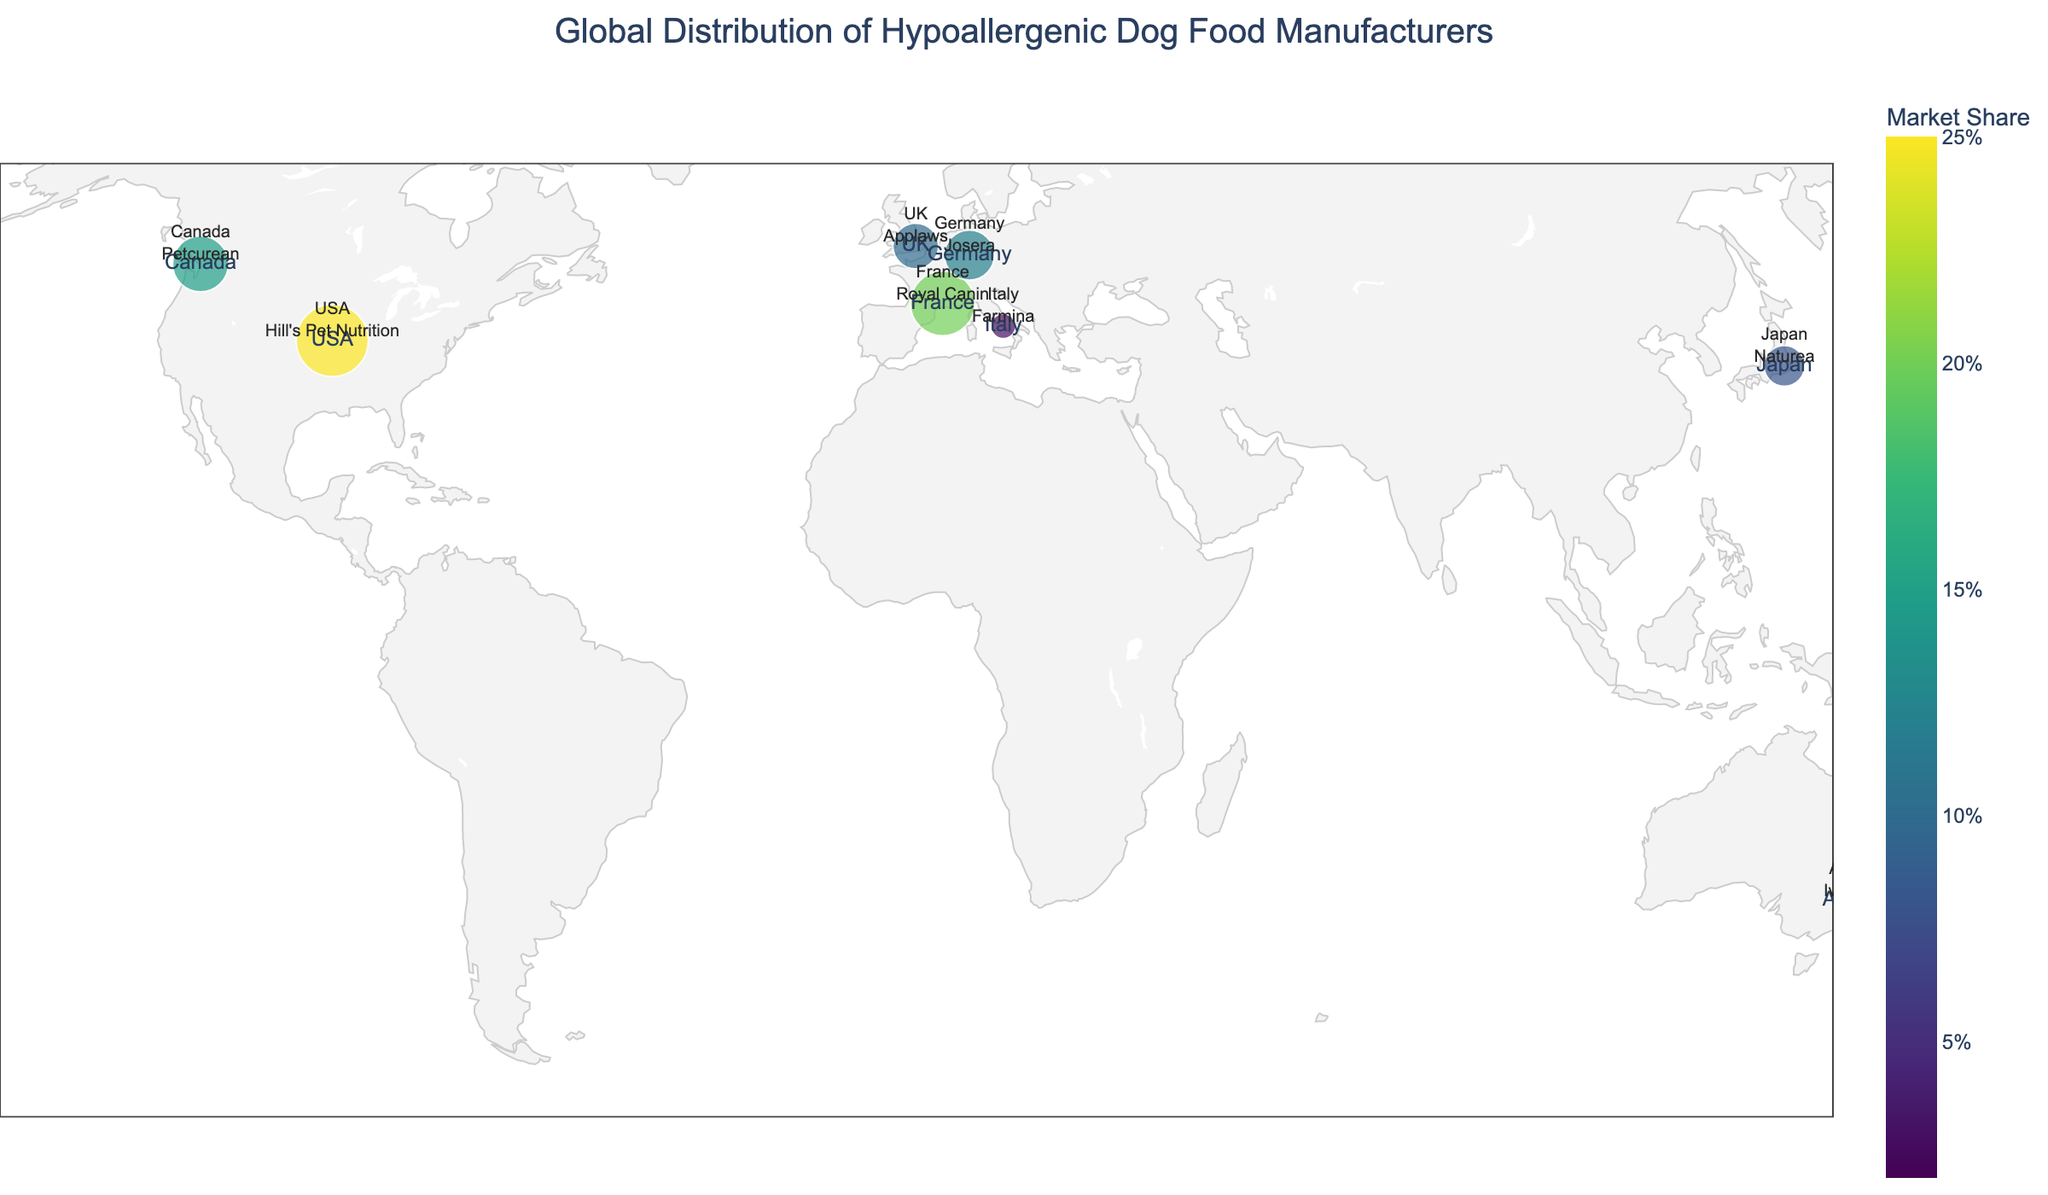What is the title of the map? The title is displayed at the top center of the map and reads "Global Distribution of Hypoallergenic Dog Food Manufacturers".
Answer: Global Distribution of Hypoallergenic Dog Food Manufacturers Which country has the largest market share of hypoallergenic dog food manufacturers? The map uses circles of different sizes to represent market share, with larger circles indicating a larger market share. The largest circle is located in the USA.
Answer: USA How many hypoallergenic dog food manufacturers are shown on the map? Each manufacturer is represented by a circle on the map. Counting all the circles gives us nine manufacturers.
Answer: Nine What is the market share of the dog food manufacturer located in Germany? The map includes a color scale to represent market share, and each manufacturer is labeled with its market share percentage. The manufacturer in Germany, Josera, has a market share of 0.12.
Answer: 0.12 Which manufacturer has the smallest market share, and where is it located? The map shows circles of varying sizes to depict market share, with the smallest circle representing the smallest market share. This circle is located in New Zealand, and the manufacturer is Ziwi.
Answer: Ziwi, New Zealand Compare the market shares of Hill's Pet Nutrition and Royal Canin. Which one is higher and by how much? The map shows Hill's Pet Nutrition with a market share of 0.25 and Royal Canin with 0.20. The difference is calculated as 0.25 - 0.20.
Answer: Hill's Pet Nutrition, by 0.05 What is the combined market share of Petcurean and Applaws? The map lists their individual market shares: Petcurean (0.15) and Applaws (0.10). Adding these gives: 0.15 + 0.10 = 0.25
Answer: 0.25 Which continents have hypoallergenic dog food manufacturers represented on this map? The map shows manufacturers located in North America (USA, Canada), Europe (France, Germany, UK, Italy), Asia (Japan), Australia, and New Zealand.
Answer: North America, Europe, Asia, and Australia Which two manufacturers have the closest market share values? Examining the market share values on the map, Naturea (0.08) and Ivory Coat (0.05) are the closest, with a difference of 0.03.
Answer: Naturea and Ivory Coat What is the average market share of all the manufacturers displayed on the map? Summing up all market shares: 0.25+0.20+0.15+0.12+0.10+0.08+0.05+0.03+0.02 and dividing by 9: (1.00)/9 ≈ 0.111
Answer: 0.111 